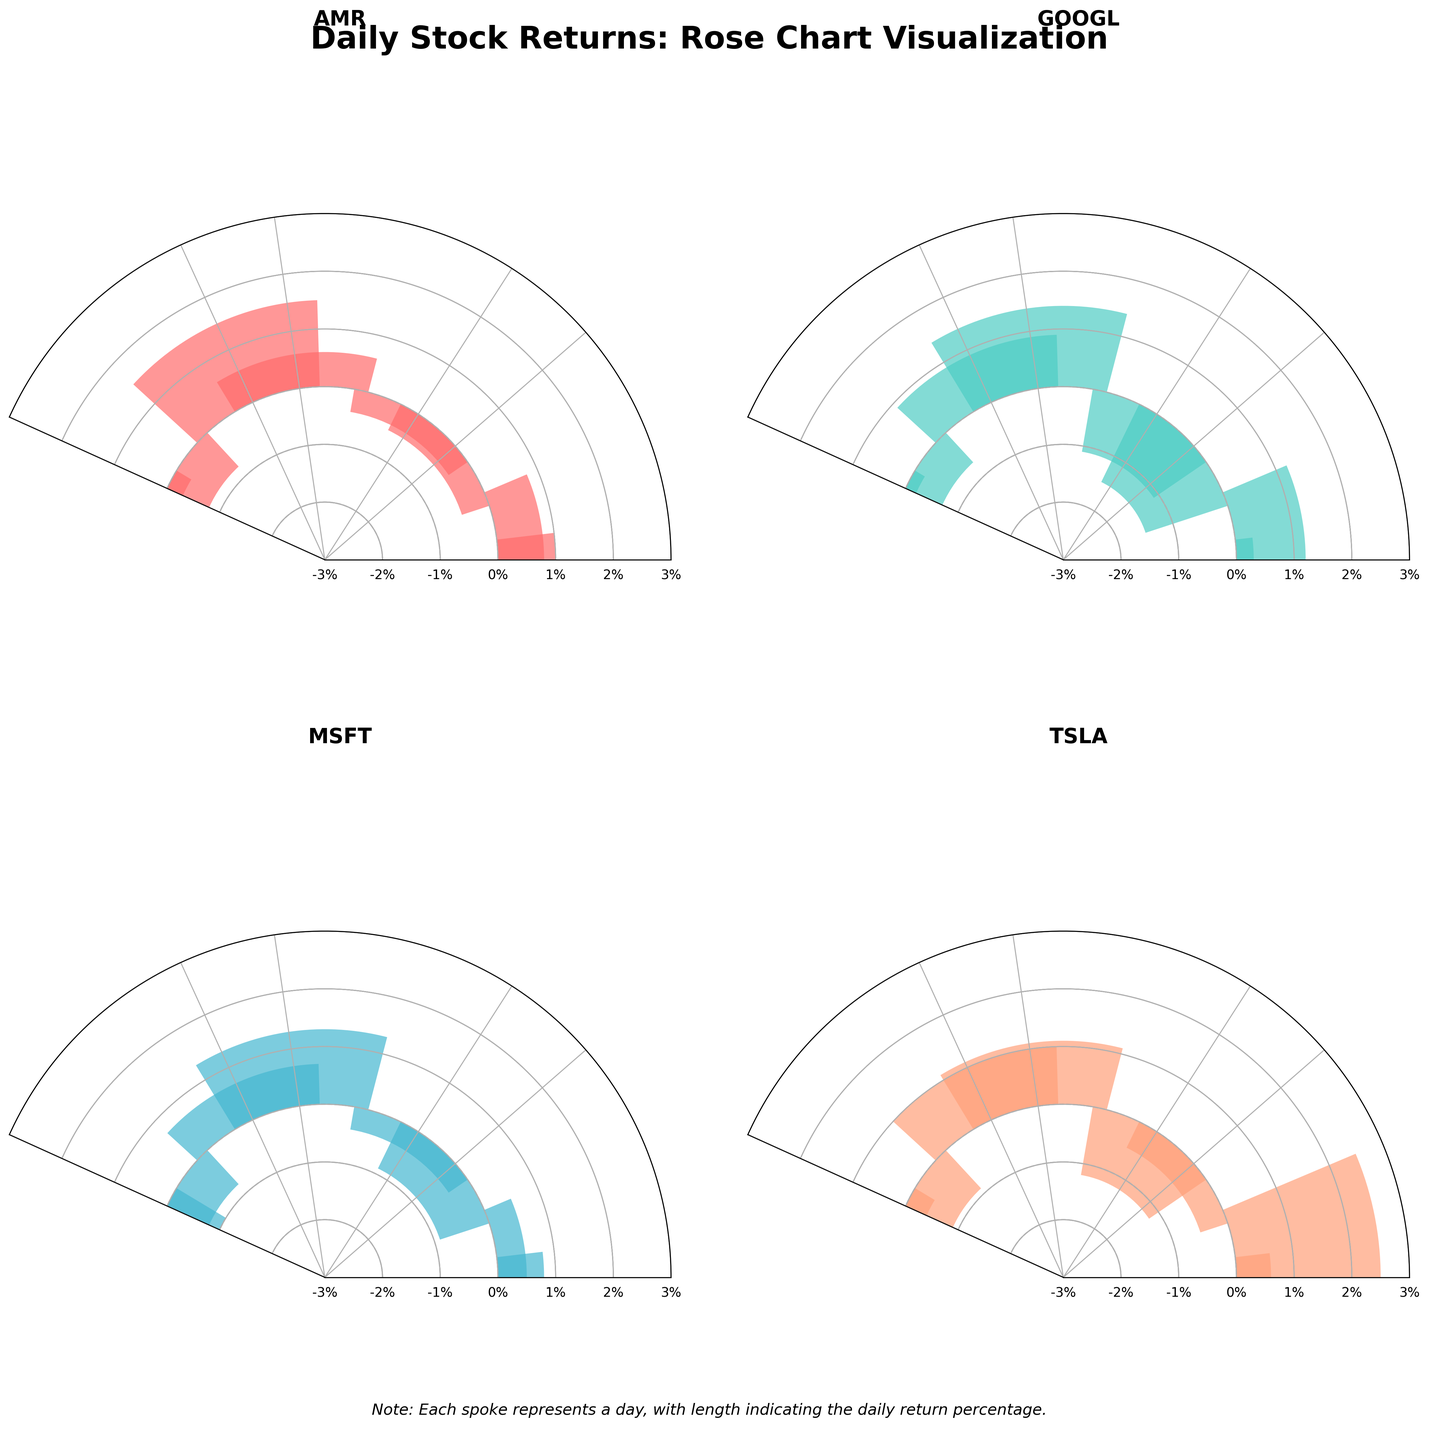What is the title of the figure? The title can be found at the top of the figure, which reads "Daily Stock Returns: Rose Chart Visualization."
Answer: Daily Stock Returns: Rose Chart Visualization How many stocks are represented in the figure? There are four subplots, each representing a different stock, indicating that there are four stocks visualized in the figure.
Answer: Four Which stock has the highest positive return on any given day? This can be determined by identifying the tallest bar reaching outward from the center. For TSLA (Tesla) on 2023-09-01, the return was 2.5%.
Answer: TSLA What color is associated with GOOGL in the figure? Each stock has a unique color. GOOGL's subplot is colored with a specific palette which appears in cyan.
Answer: Cyan Which stock experienced the greatest volatility in the given period? Volatility can be assessed by looking at the range of returns and the spread of bars in the subplot. TSLA exhibits substantial variations and a broader range of returns.
Answer: TSLA What is the range of returns for AMR? Observing the bars for AMR's subplot shows the daily returns stretch from -2.1% to 1.5%, giving a range of (1.5 - (-2.1)) = 3.6%.
Answer: 3.6% Between AMR and MSFT, which stock had more negative return days? Counting the negative bars in each subplot for AMR (5 days) and MSFT (5 days) shows they both had the same number of negative return days.
Answer: Both had 5 Which stock had the least negative impact day and what was its value? By looking at the shortest negative bar, AMR had a return of -0.3% on 2023-09-04, which is the smallest negative return.
Answer: AMR, -0.3% What are the y-axis labels representing in the figure? The y-axis labels denote the daily return percentages, which are displayed in a circular format around the center.
Answer: Daily return percentages 